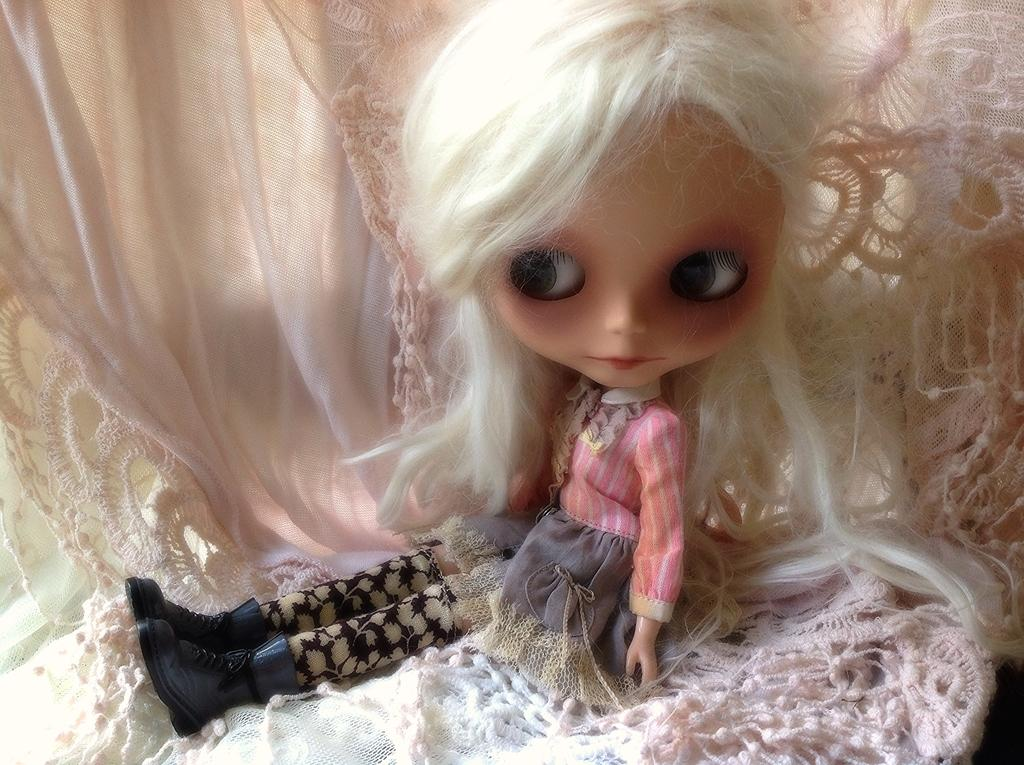What is the main subject of the image? There is a Barbie doll in the image. Can you describe the background of the image? There is a cloth in the background of the image. How many men can be seen in the image? There are no men present in the image; it features a Barbie doll and a cloth background. What type of stamp is visible on the Barbie doll? There is no stamp present on the Barbie doll in the image. 